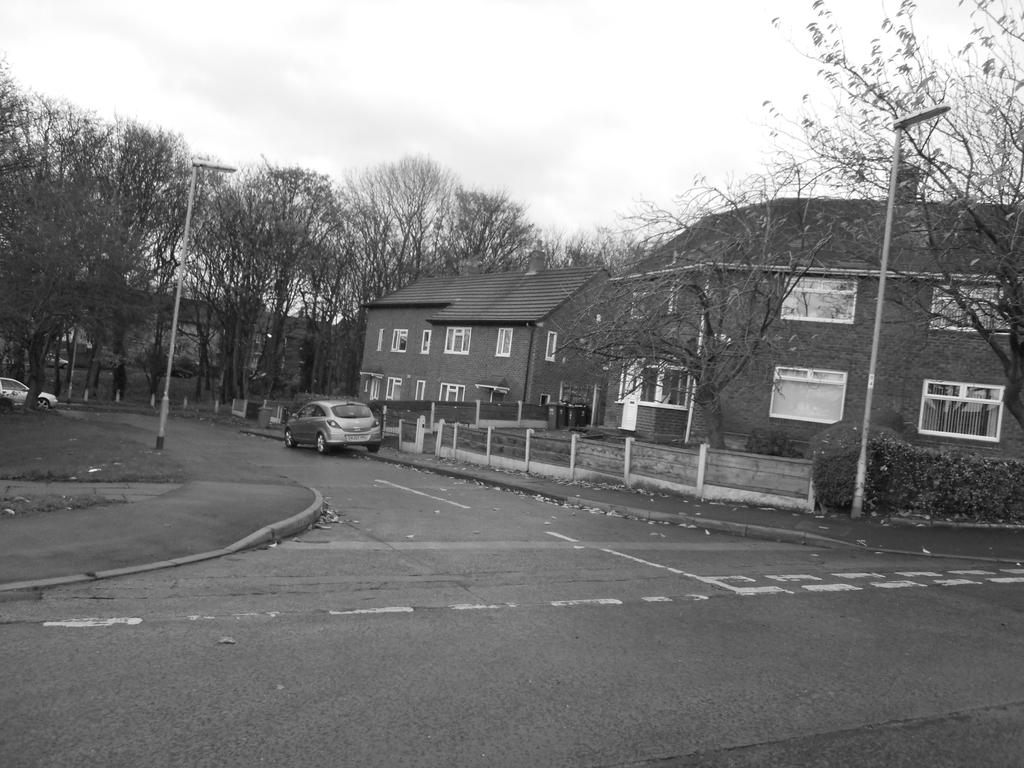What can be seen in the background of the image? There are buildings and trees in the background of the image. What is present on the road in the image? There are cars on the road in the image. What feature surrounds the building in the image? There is a boundary around the building. Can you see any veins in the image? There are no veins visible in the image. How many cows are present in the image? There are no cows present in the image. 